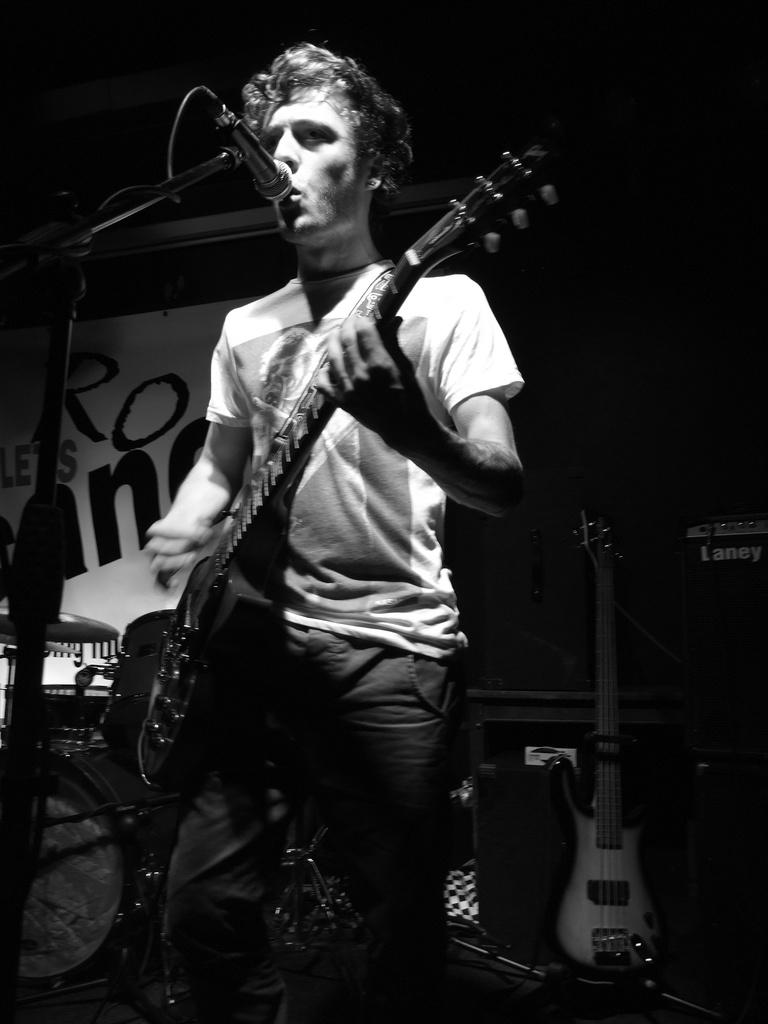Who is present in the image? There is a man in the image. What is the man doing in the image? The man is standing in the image. What object is the man holding in the image? The man is holding a guitar in the image. What other object can be seen in the image? There is a microphone in the image. What is the purpose of the stand in the image? There is a stand in the image, which might be used to support the guitar or other equipment. Can you see a crow flying in the image? There is no crow present in the image. What type of wristwatch is the man wearing in the image? The man is not wearing a wristwatch in the image. 